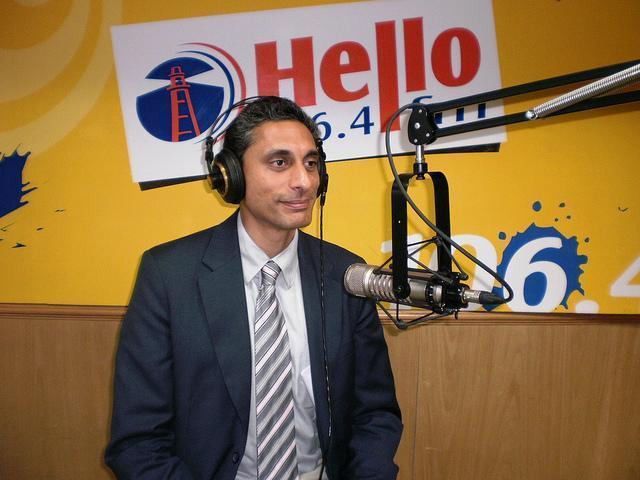How many people are standing to the left of the open train door?
Give a very brief answer. 0. 